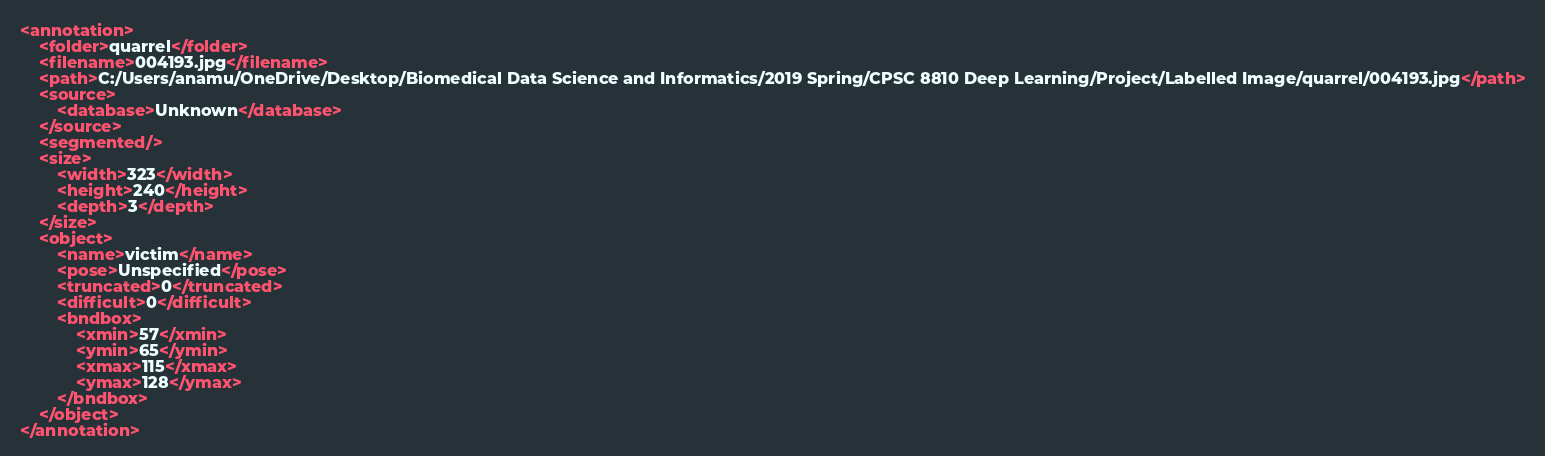<code> <loc_0><loc_0><loc_500><loc_500><_XML_><annotation>
	<folder>quarrel</folder>
	<filename>004193.jpg</filename>
	<path>C:/Users/anamu/OneDrive/Desktop/Biomedical Data Science and Informatics/2019 Spring/CPSC 8810 Deep Learning/Project/Labelled Image/quarrel/004193.jpg</path>
	<source>
		<database>Unknown</database>
	</source>
	<segmented/>
	<size>
		<width>323</width>
		<height>240</height>
		<depth>3</depth>
	</size>
	<object>
		<name>victim</name>
		<pose>Unspecified</pose>
		<truncated>0</truncated>
		<difficult>0</difficult>
		<bndbox>
			<xmin>57</xmin>
			<ymin>65</ymin>
			<xmax>115</xmax>
			<ymax>128</ymax>
		</bndbox>
	</object>
</annotation>
</code> 